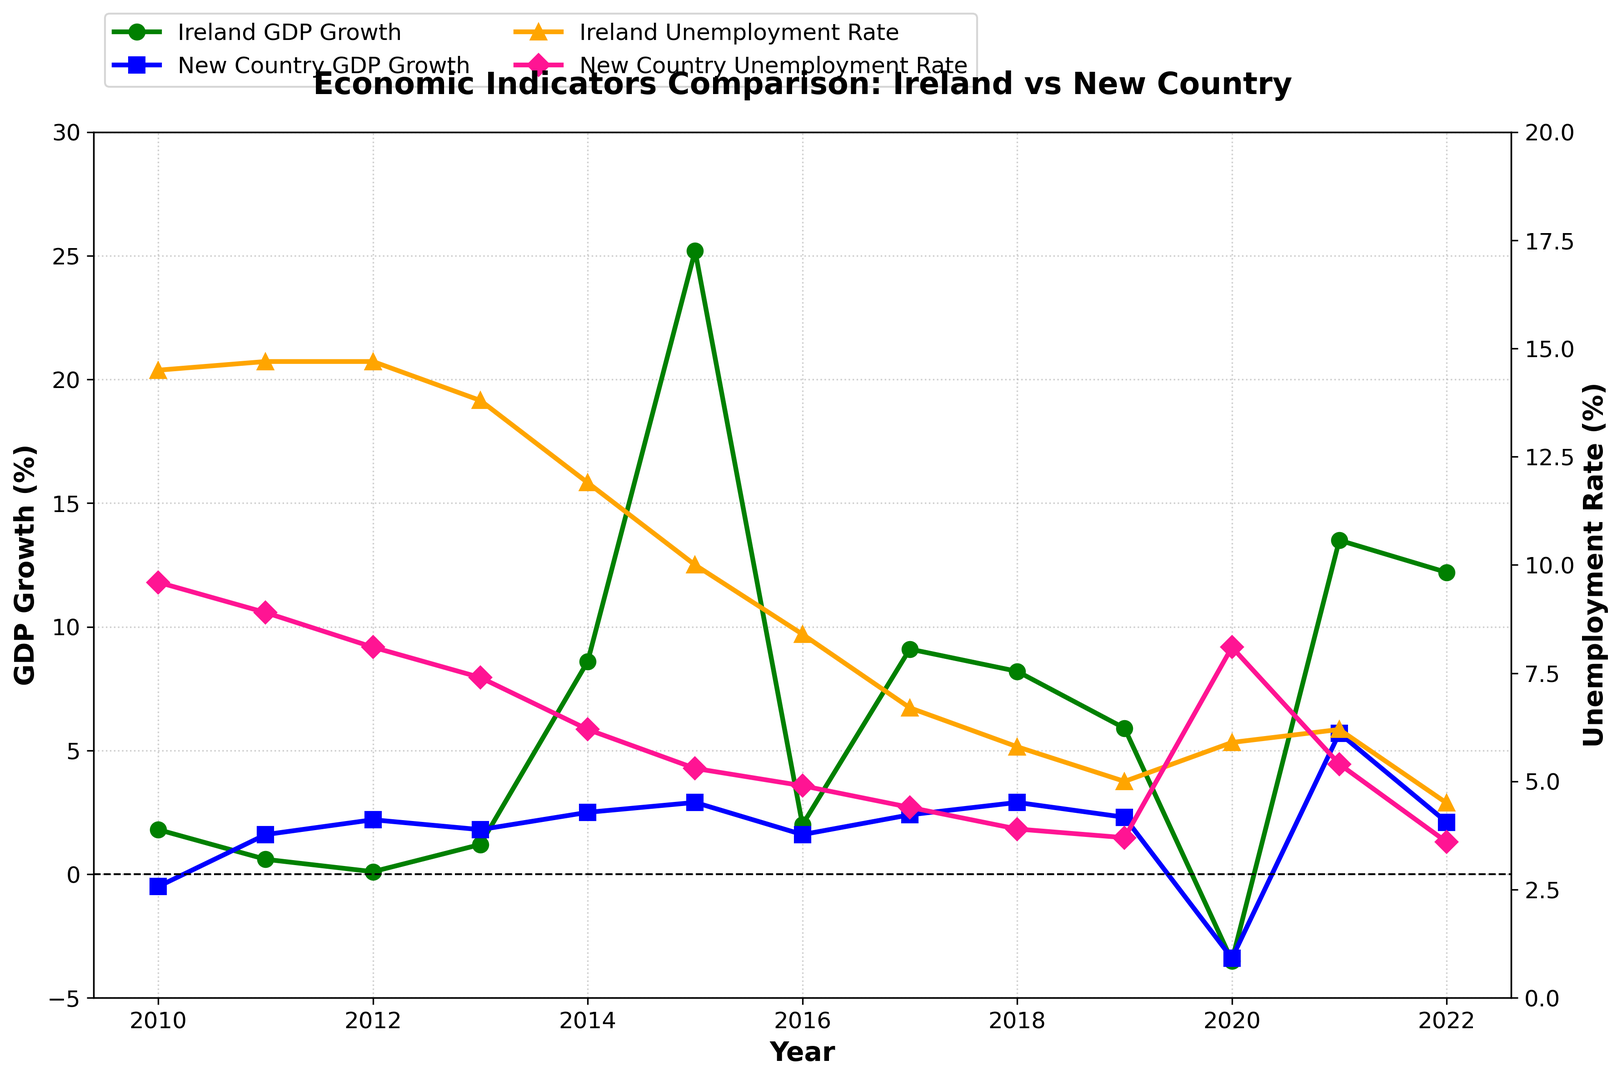Which year did Ireland experience the highest GDP growth? Look for the highest point on the line representing Ireland's GDP growth. The peak occurs in 2015, where Ireland's GDP growth is 25.2%.
Answer: 2015 Which country had a lower unemployment rate in 2016? Compare the unemployment rates for Ireland and the new country in 2016. For Ireland, it's 8.4%, and for the new country, it's 4.9%. 4.9% is lower than 8.4%.
Answer: New country What is the difference in GDP growth between Ireland and the new country in 2020? Look for the GDP growth rates for both countries in 2020. Ireland’s GDP growth is -3.5%, and the new country’s GDP growth is -3.4%. Subtract -3.4% from -3.5% to find the difference.
Answer: 0.1% Which year did Ireland's unemployment rate fall below 10% for the first time since 2010? Trace the line representing Ireland’s unemployment rate and identify the first year it falls below 10%. This occurs in 2015, where the rate is 10.0% but falls to 8.4% in 2016.
Answer: 2016 In which year did the new country have its highest unemployment rate, and what was it? Find the peak of the line representing the new country’s unemployment rate. In 2020, the new country’s unemployment rate reaches 8.1%.
Answer: 2020, 8.1% Compare the GDP growth rates of both countries in 2021 and identify which country had higher GDP growth. Check the GDP growth values for both countries in 2021. Ireland’s GDP growth is 13.5%, and the new country's GDP growth is 5.7%. 13.5% is higher than 5.7%.
Answer: Ireland By how much did Ireland's GDP growth change from 2010 to 2011? Compare the GDP growth rates for Ireland in 2010 and 2011. Subtract the 2011 value (0.6%) from the 2010 value (1.8%).
Answer: Decreased by 1.2% What is the average unemployment rate in the new country over the first three years (2010-2012)? Add the unemployment rates for the new country from 2010 (9.6%), 2011 (8.9%), and 2012 (8.1%) and divide by 3 to find the average.
Answer: 8.87% Did Ireland experience GDP decline, and in which years did it occur? Look for the years when Ireland’s GDP growth values are negative. Negative GDP growth is observed in 2020 with -3.5%.
Answer: Yes, in 2020 Between Ireland and the new country, which one had a higher unemployment rate in 2014? Compare the unemployment rates for both countries in 2014. Ireland's unemployment rate is 11.9%, while the new country’s rate is 6.2%. 11.9% is higher than 6.2%.
Answer: Ireland 